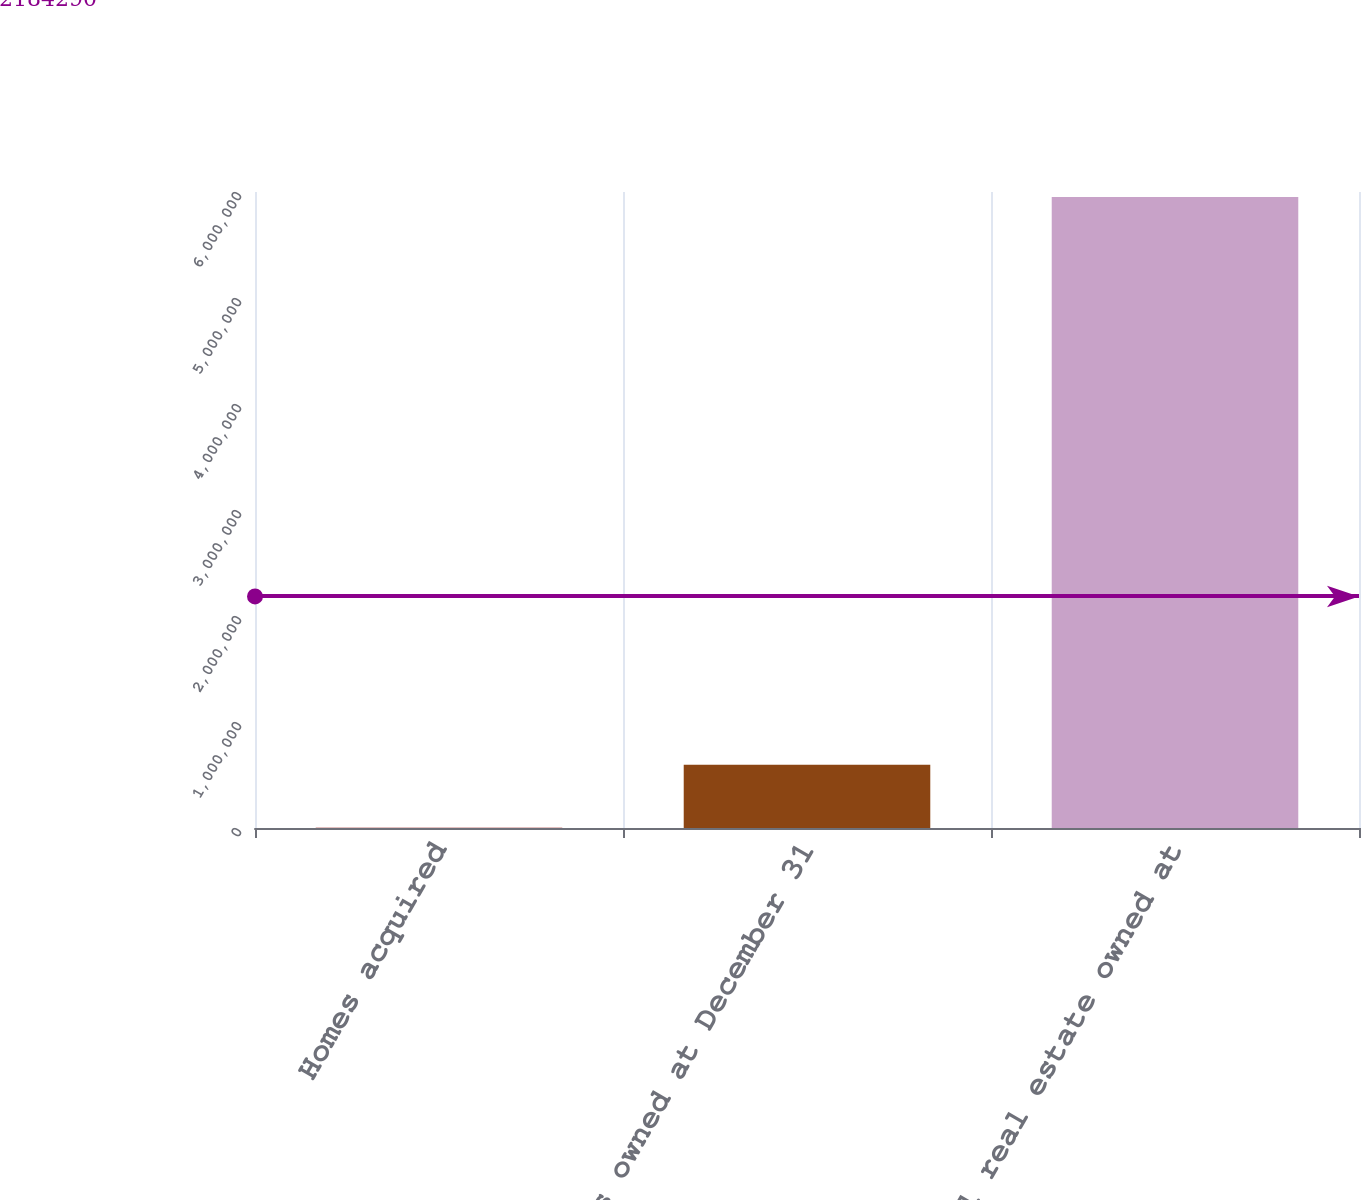<chart> <loc_0><loc_0><loc_500><loc_500><bar_chart><fcel>Homes acquired<fcel>Homes owned at December 31<fcel>Total real estate owned at<nl><fcel>2671<fcel>597658<fcel>5.95254e+06<nl></chart> 